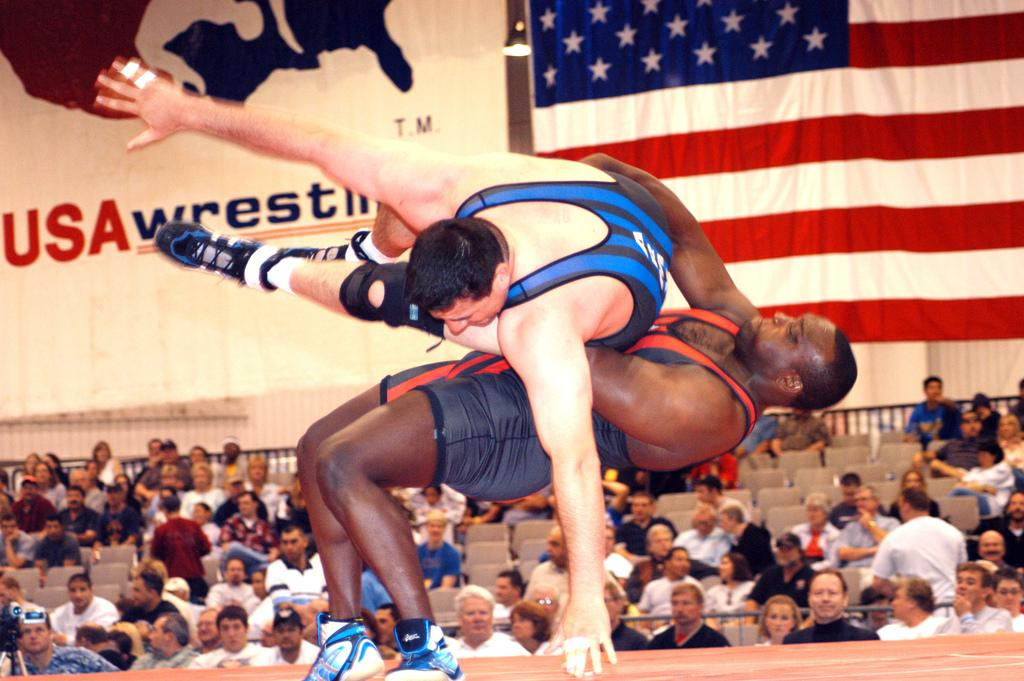<image>
Give a short and clear explanation of the subsequent image. Two wrestlers are having a match at the USA wrestling tournament. 